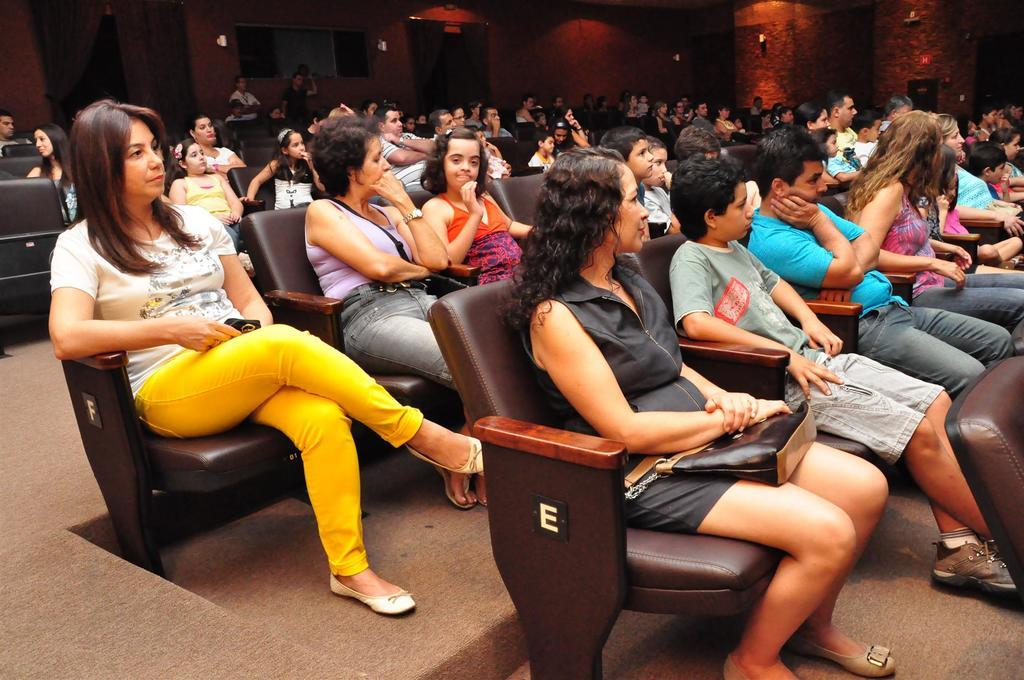What is the general setting of the image? There is a group of people sitting in the image. Can you describe the clothing of one person in the group? One person in the group is wearing a white shirt and yellow pants. What can be seen in the background of the image? There are lights and doors visible in the background of the image. What type of bottle is being used to answer questions in the image? There is no bottle present in the image, nor is there any indication that the group is answering questions. 